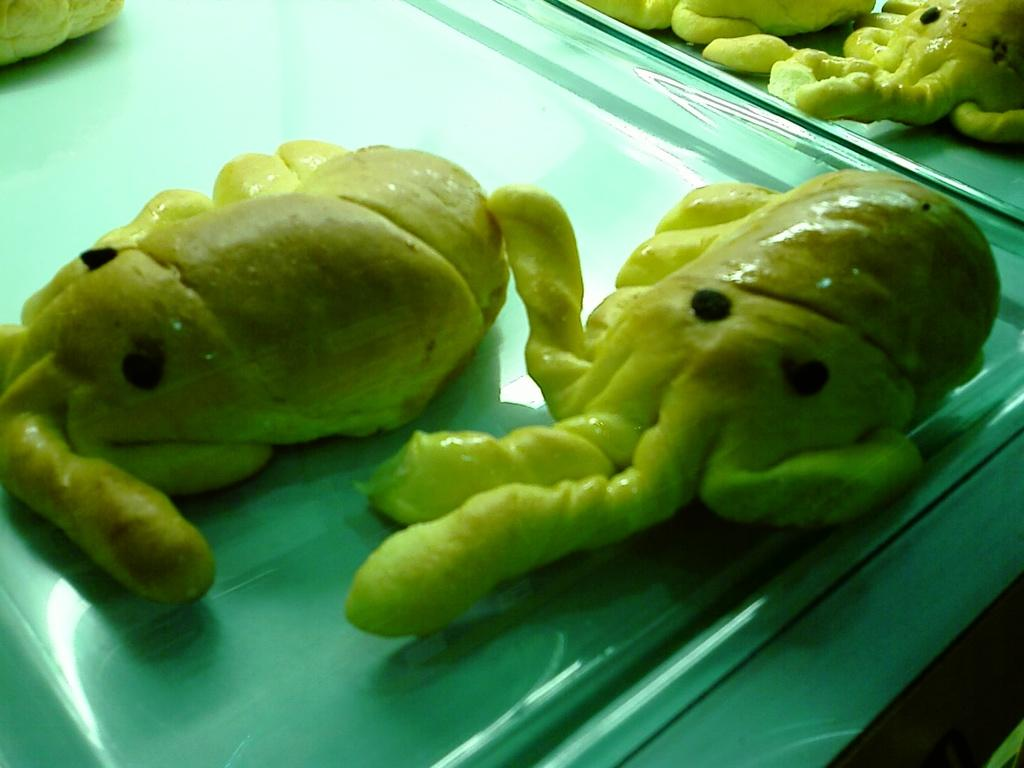What can be seen in the image related to food? There is a food item in the image. What type of furniture or storage is present in the image? There is a shelf in the image. What type of truck can be seen in the image? There is no truck present in the image. What color is the pear on the shelf in the image? There is no pear present in the image. 